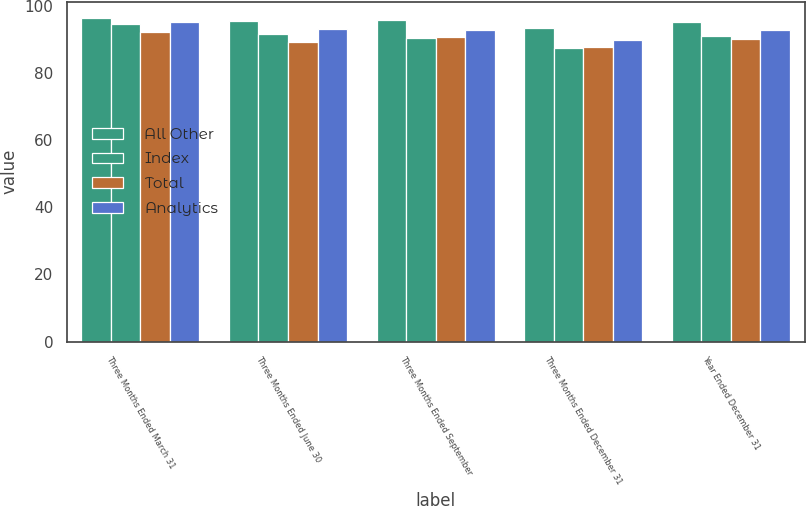Convert chart. <chart><loc_0><loc_0><loc_500><loc_500><stacked_bar_chart><ecel><fcel>Three Months Ended March 31<fcel>Three Months Ended June 30<fcel>Three Months Ended September<fcel>Three Months Ended December 31<fcel>Year Ended December 31<nl><fcel>All Other<fcel>96.3<fcel>95.6<fcel>95.8<fcel>93.4<fcel>95.3<nl><fcel>Index<fcel>94.6<fcel>91.7<fcel>90.4<fcel>87.4<fcel>91<nl><fcel>Total<fcel>92.2<fcel>89.2<fcel>90.8<fcel>87.8<fcel>90<nl><fcel>Analytics<fcel>95.1<fcel>93.1<fcel>92.7<fcel>89.9<fcel>92.7<nl></chart> 